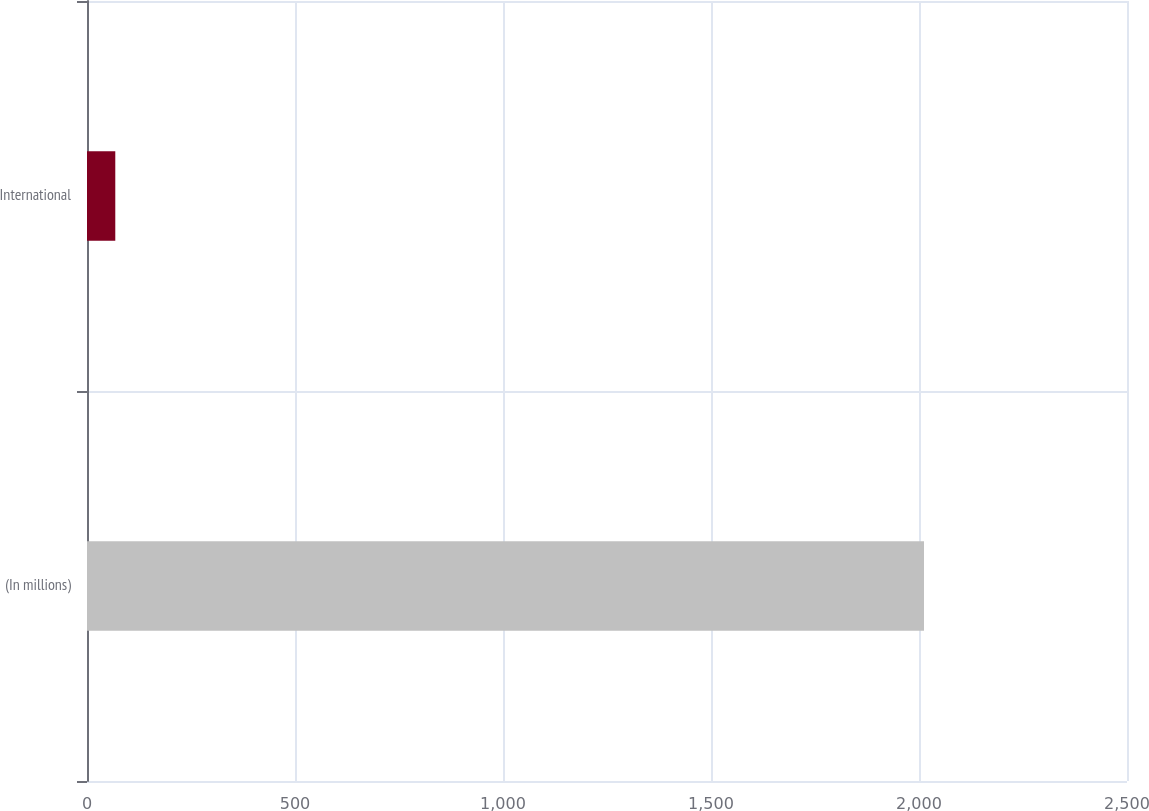Convert chart to OTSL. <chart><loc_0><loc_0><loc_500><loc_500><bar_chart><fcel>(In millions)<fcel>International<nl><fcel>2012<fcel>68<nl></chart> 